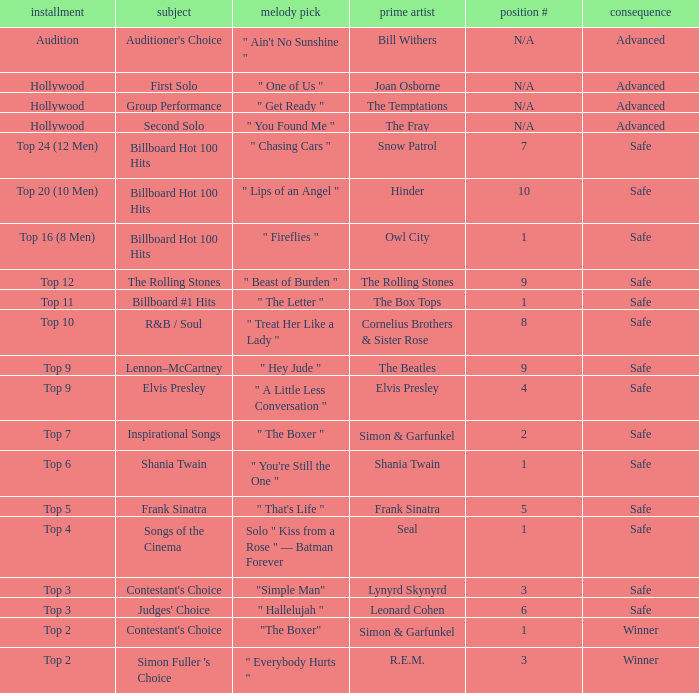In episode Top 16 (8 Men), what are the themes? Billboard Hot 100 Hits. 